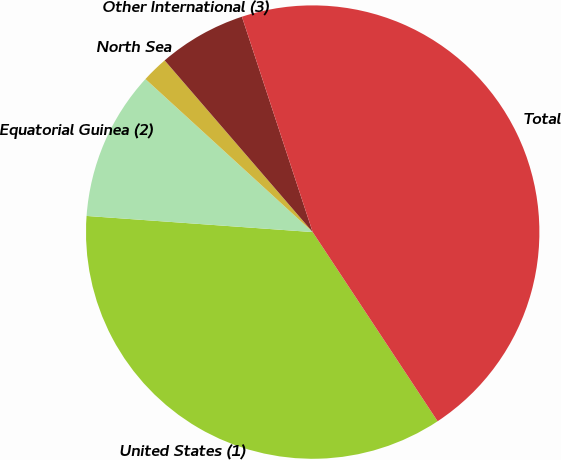Convert chart. <chart><loc_0><loc_0><loc_500><loc_500><pie_chart><fcel>United States (1)<fcel>Equatorial Guinea (2)<fcel>North Sea<fcel>Other International (3)<fcel>Total<nl><fcel>35.42%<fcel>10.66%<fcel>1.88%<fcel>6.27%<fcel>45.76%<nl></chart> 